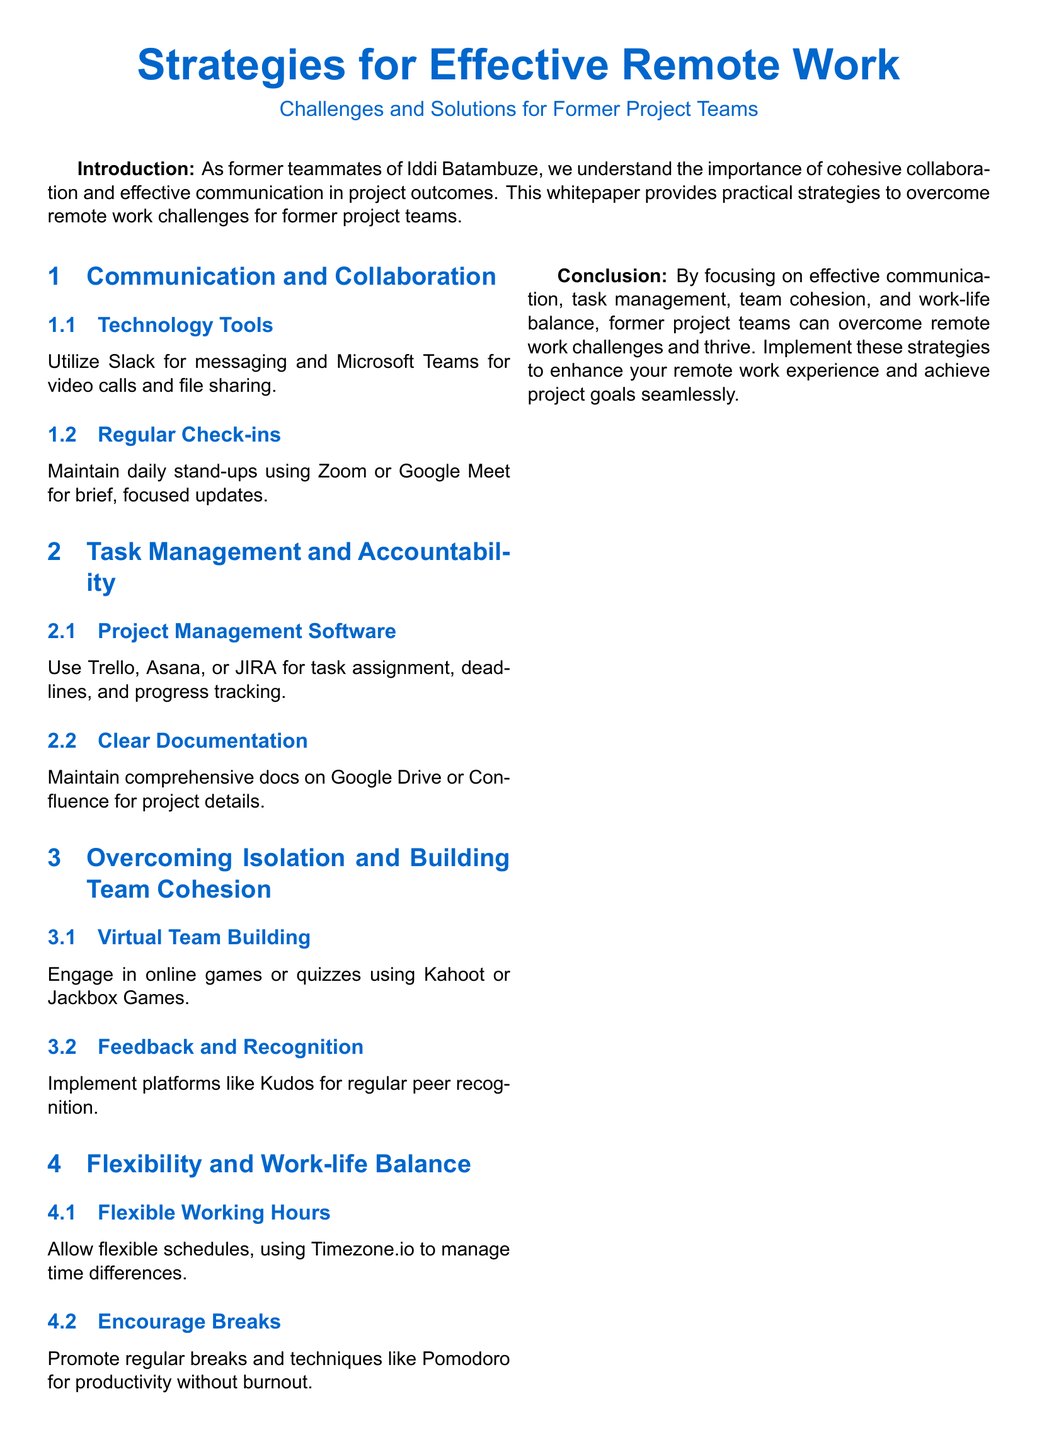What are the two main themes of the whitepaper? The two main themes highlighted in the document are communication and collaboration, and task management and accountability.
Answer: communication and collaboration, task management and accountability What technology tool is recommended for messaging? The document recommends Slack for messaging.
Answer: Slack Which platform is suggested for regular video calls? Regular video calls should be conducted using Microsoft Teams.
Answer: Microsoft Teams What should be maintained on Google Drive or Confluence? Comprehensive documents regarding project details should be maintained on Google Drive or Confluence.
Answer: comprehensive docs What game platforms are mentioned for virtual team building? Kahoot and Jackbox Games are suggested for virtual team building activities.
Answer: Kahoot, Jackbox Games What technique is recommended to promote productivity without burnout? The Pomodoro technique is recommended to promote productivity without burnout.
Answer: Pomodoro How should former project teams address work-life balance? They should allow flexible working hours to address work-life balance.
Answer: flexible working hours What is the primary goal of implementing the strategies outlined in this whitepaper? The primary goal is to enhance remote work experience and achieve project goals seamlessly.
Answer: enhance remote work experience and achieve project goals seamlessly 